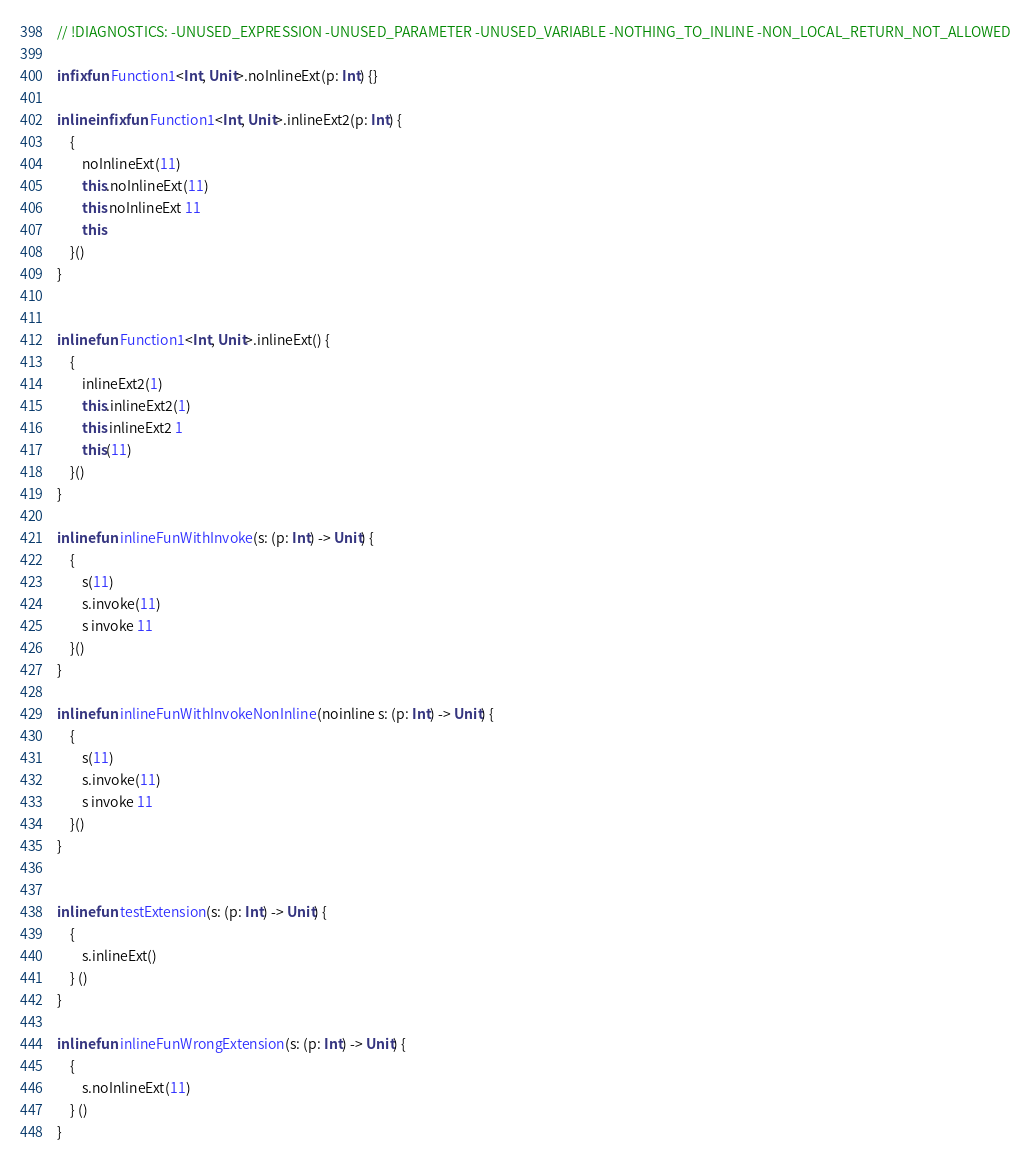Convert code to text. <code><loc_0><loc_0><loc_500><loc_500><_Kotlin_>// !DIAGNOSTICS: -UNUSED_EXPRESSION -UNUSED_PARAMETER -UNUSED_VARIABLE -NOTHING_TO_INLINE -NON_LOCAL_RETURN_NOT_ALLOWED

infix fun Function1<Int, Unit>.noInlineExt(p: Int) {}

inline infix fun Function1<Int, Unit>.inlineExt2(p: Int) {
    {
        noInlineExt(11)
        this.noInlineExt(11)
        this noInlineExt 11
        this
    }()
}


inline fun Function1<Int, Unit>.inlineExt() {
    {
        inlineExt2(1)
        this.inlineExt2(1)
        this inlineExt2 1
        this(11)
    }()
}

inline fun inlineFunWithInvoke(s: (p: Int) -> Unit) {
    {
        s(11)
        s.invoke(11)
        s invoke 11
    }()
}

inline fun inlineFunWithInvokeNonInline(noinline s: (p: Int) -> Unit) {
    {
        s(11)
        s.invoke(11)
        s invoke 11
    }()
}


inline fun testExtension(s: (p: Int) -> Unit) {
    {
        s.inlineExt()
    } ()
}

inline fun inlineFunWrongExtension(s: (p: Int) -> Unit) {
    {
        s.noInlineExt(11)
    } ()
}</code> 